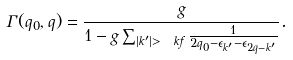<formula> <loc_0><loc_0><loc_500><loc_500>\Gamma ( q _ { 0 } , q ) = \frac { g } { 1 - g \sum _ { | k ^ { \prime } | > \ k f } \frac { 1 } { 2 q _ { 0 } - \epsilon _ { k ^ { \prime } } - \epsilon _ { 2 q - k ^ { \prime } } } } .</formula> 